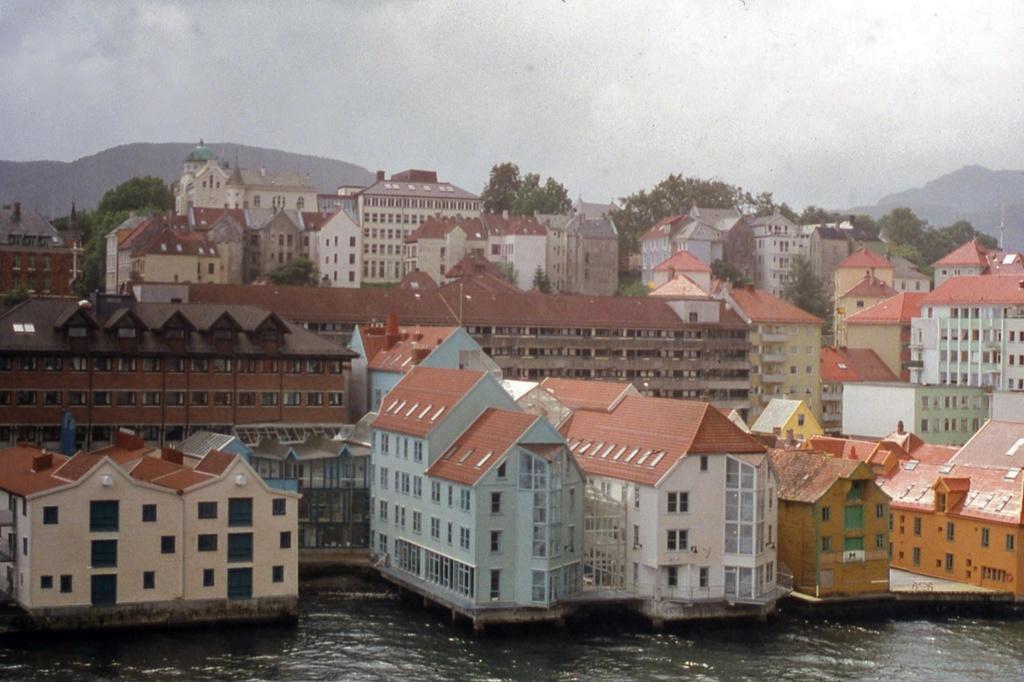Describe this image in one or two sentences. In this picture I can see the water at the bottom, in the middle there are buildings and trees. At the top there is the sky. 